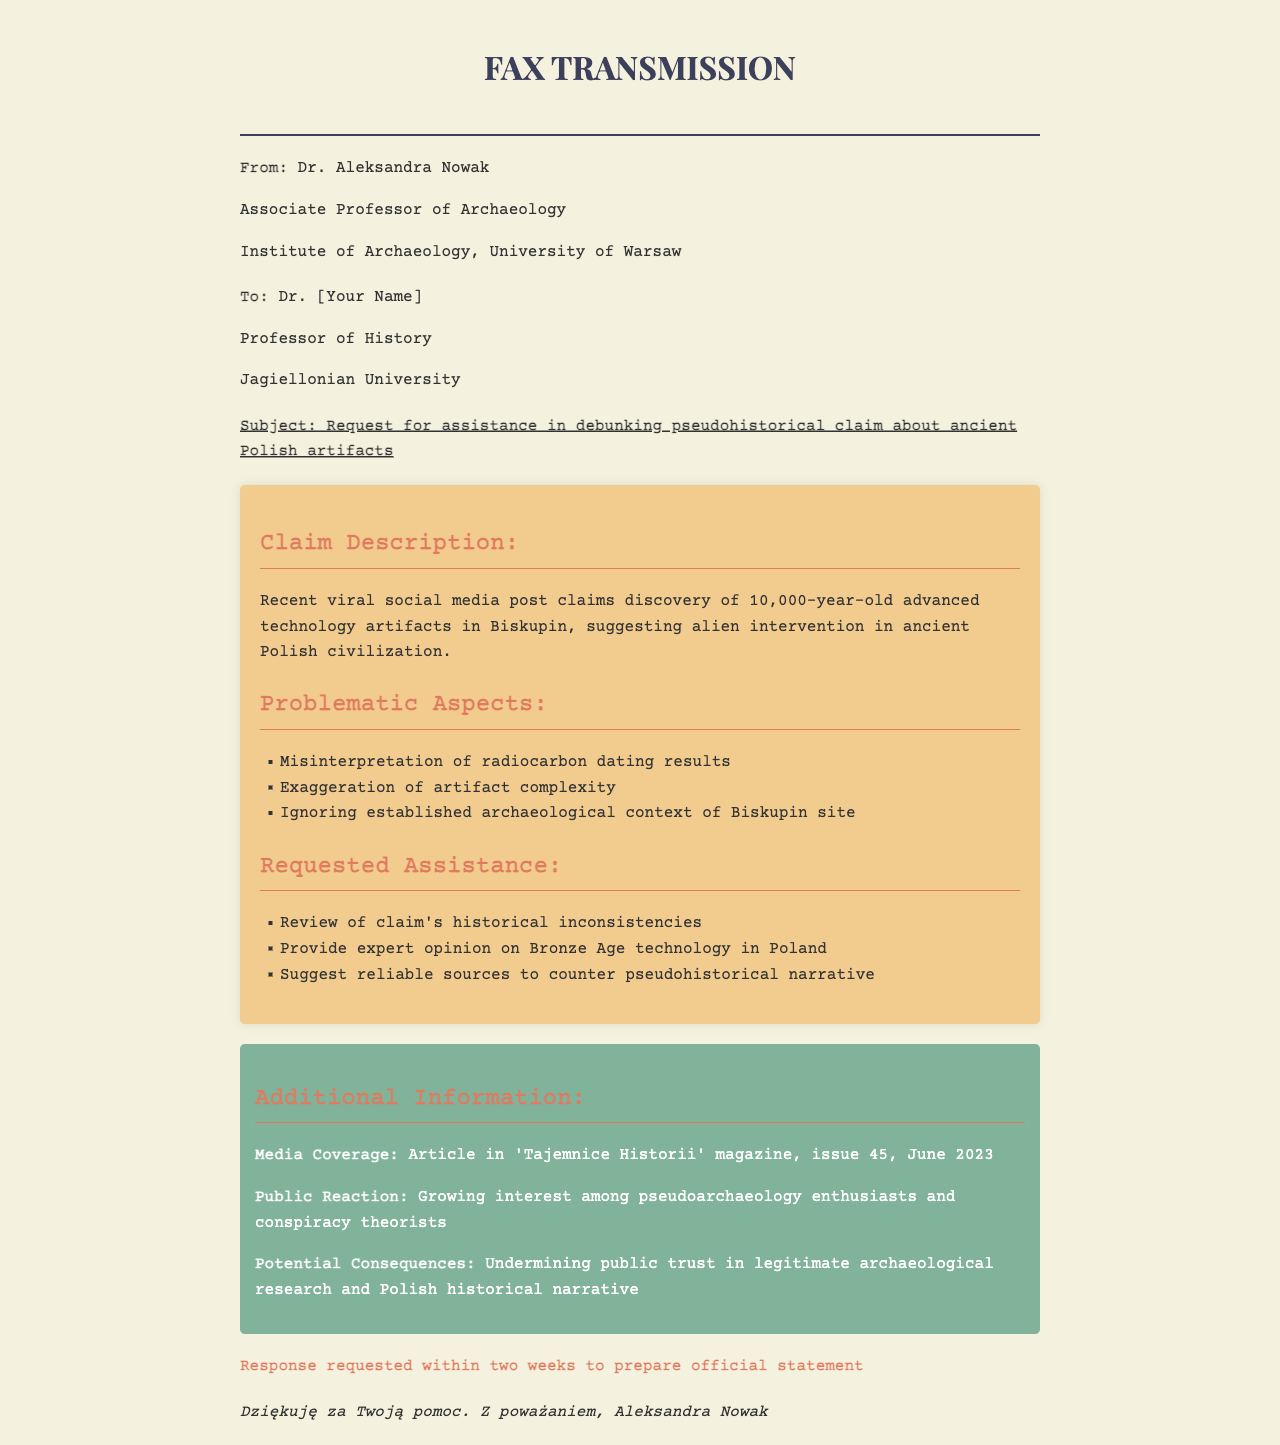What is the sender's name? The sender is Dr. Aleksandra Nowak, as stated in the sender information.
Answer: Dr. Aleksandra Nowak What is the recipient's title? The recipient is addressed as Dr. [Your Name], which indicates their title is Dr.
Answer: Dr What is the main subject of the fax? The subject clearly states the request for assistance in debunking a pseudohistorical claim.
Answer: Request for assistance in debunking pseudohistorical claim about ancient Polish artifacts What is the alleged age of the artifacts? The claim specifies that the artifacts are 10,000 years old.
Answer: 10,000-year-old Which site is mentioned in the claim? The site referenced in the claim is Biskupin.
Answer: Biskupin What does the sender request in terms of historical analysis? The sender requests a review of the claim's historical inconsistencies.
Answer: Review of claim's historical inconsistencies What is the media outlet mentioned? The additional information section includes an article in 'Tajemnice Historii' magazine.
Answer: 'Tajemnice Historii' What is the response time requested? The document indicates that a response is requested within two weeks.
Answer: Two weeks 